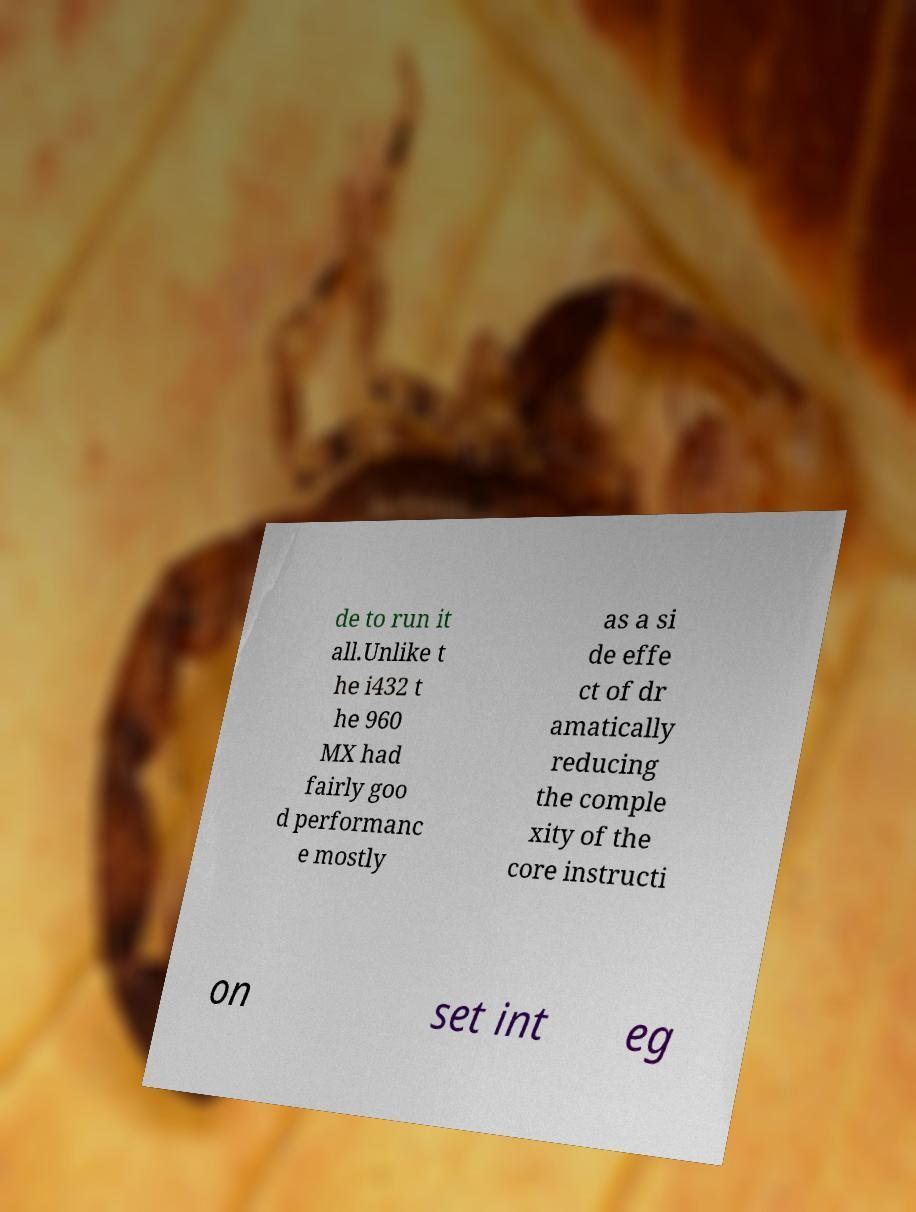For documentation purposes, I need the text within this image transcribed. Could you provide that? de to run it all.Unlike t he i432 t he 960 MX had fairly goo d performanc e mostly as a si de effe ct of dr amatically reducing the comple xity of the core instructi on set int eg 